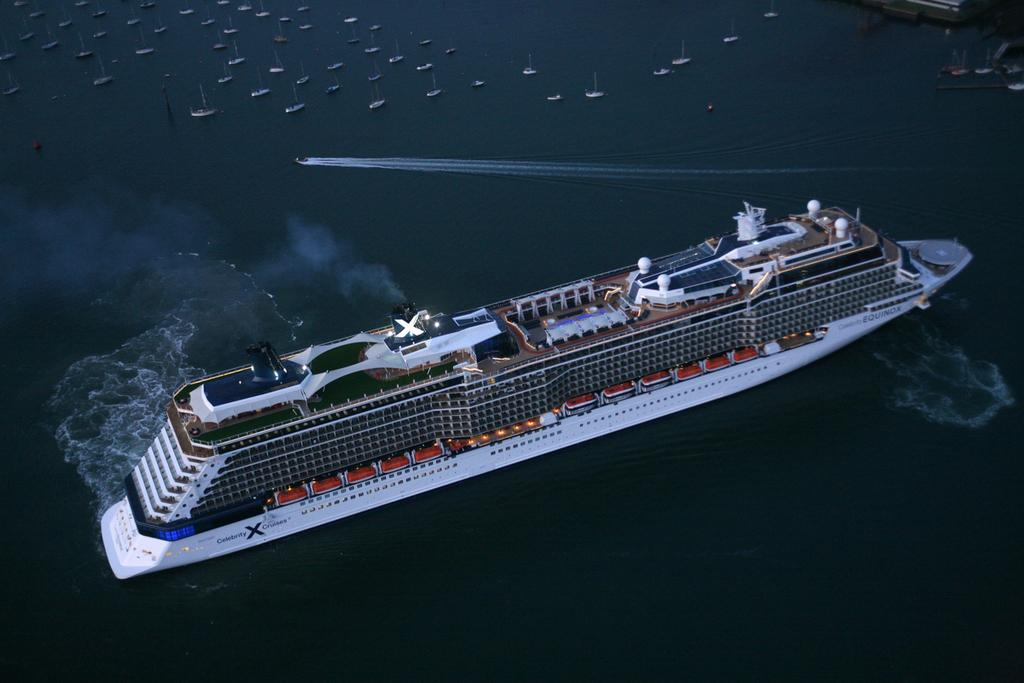What is the main subject of the image? The main subject of the image is a ship sailing in the water. Are there any other watercraft visible in the image? Yes, there are boats sailing in the water at the top of the image. Where is the bedroom located in the image? There is no bedroom present in the image; it features a ship and boats sailing in the water. What type of cap is the ship wearing in the image? There is no cap present in the image; it features a ship and boats sailing in the water. 